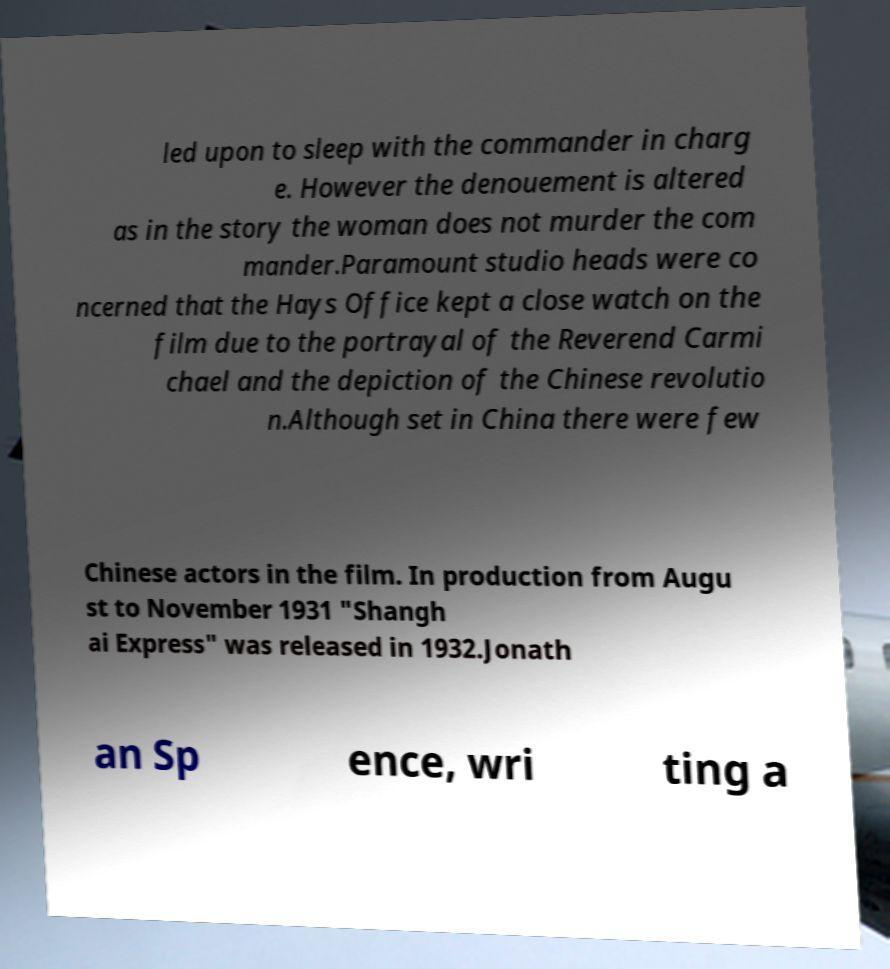There's text embedded in this image that I need extracted. Can you transcribe it verbatim? led upon to sleep with the commander in charg e. However the denouement is altered as in the story the woman does not murder the com mander.Paramount studio heads were co ncerned that the Hays Office kept a close watch on the film due to the portrayal of the Reverend Carmi chael and the depiction of the Chinese revolutio n.Although set in China there were few Chinese actors in the film. In production from Augu st to November 1931 "Shangh ai Express" was released in 1932.Jonath an Sp ence, wri ting a 